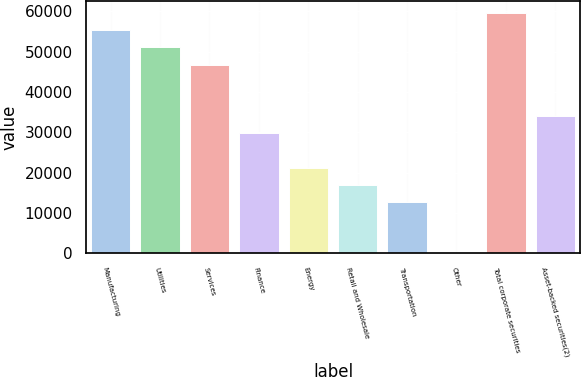<chart> <loc_0><loc_0><loc_500><loc_500><bar_chart><fcel>Manufacturing<fcel>Utilities<fcel>Services<fcel>Finance<fcel>Energy<fcel>Retail and Wholesale<fcel>Transportation<fcel>Other<fcel>Total corporate securities<fcel>Asset-backed securities(2)<nl><fcel>55289.8<fcel>51036.8<fcel>46783.9<fcel>29772.2<fcel>21266.3<fcel>17013.4<fcel>12760.5<fcel>1.69<fcel>59542.7<fcel>34025.1<nl></chart> 